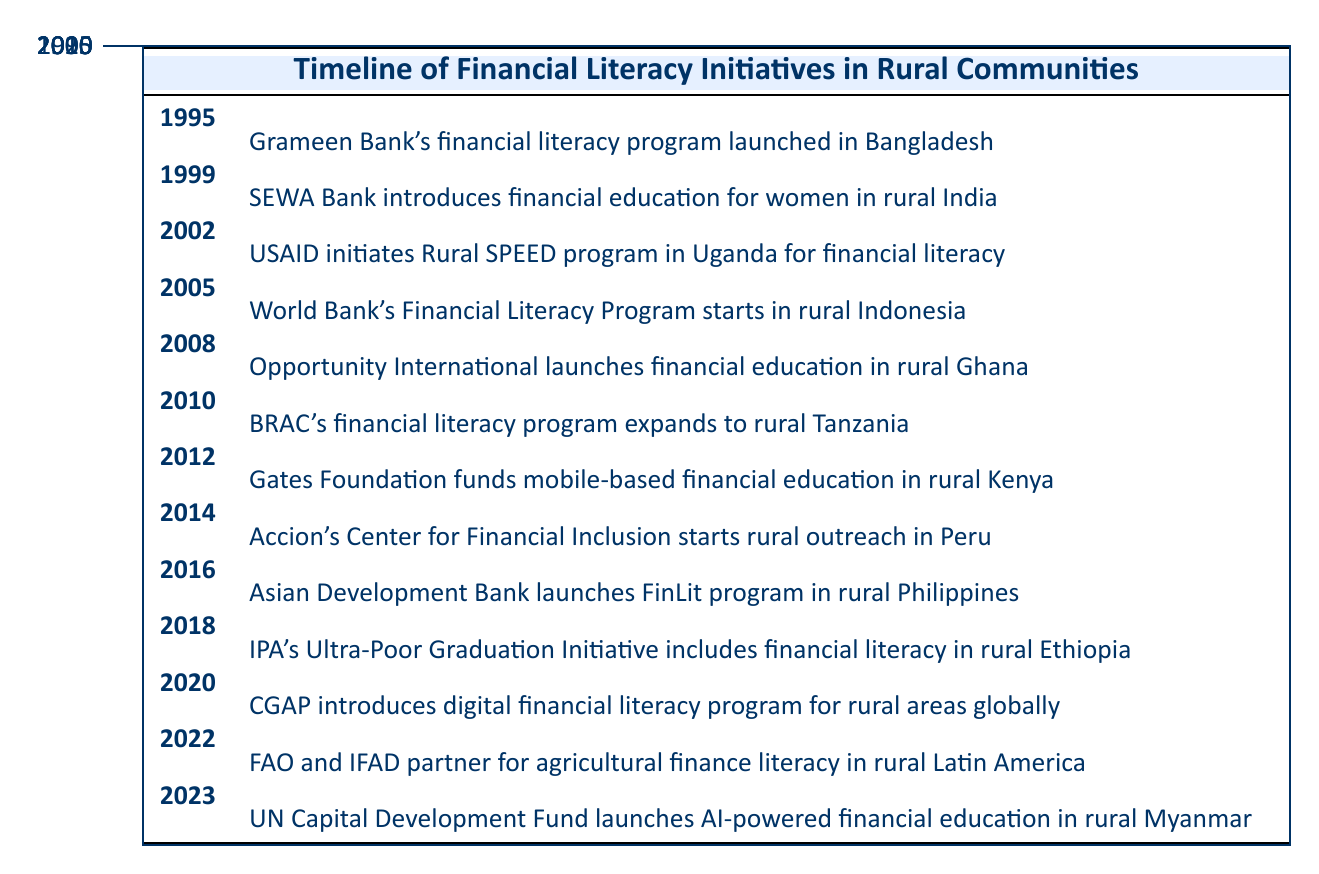What year did Grameen Bank launch its financial literacy program? From the timeline table, Grameen Bank's financial literacy program was launched in the year 1995.
Answer: 1995 How many financial literacy initiatives were launched between 2000 and 2010? The events between 2000 and 2010 are in the years 2005, 2008, and 2010. That totals to three initiatives.
Answer: 3 Did the USAID initiate a financial literacy program prior to 2002? According to the table, the USAID's Rural SPEED program was started in 2002. Thus, no financial literacy programs by USAID were initiated prior to that year.
Answer: No What was the first financial literacy program launched in Africa according to the table? In the table, the first financial literacy program mentioned in Africa is Opportunity International's financial education initiative launched in rural Ghana in 2008.
Answer: Opportunity International's financial education in rural Ghana How many years apart were the financial literacy initiatives launched in 2008 and 2010? The initiative launched in 2008 was Opportunity International's program, and the one in 2010 was BRAC's program. The difference between these years is 2010 - 2008 = 2 years.
Answer: 2 years Which initiative was funded by the Gates Foundation? The table mentions that the Gates Foundation funded mobile-based financial education in rural Kenya in 2012.
Answer: Gates Foundation's initiative in rural Kenya Identify the last financial literacy initiative listed in the table. The last entry in the timeline is from 2023, where the UN Capital Development Fund launched AI-powered financial education in rural Myanmar.
Answer: UN Capital Development Fund in rural Myanmar Was there a financial literacy initiative related to agricultural finance in Latin America? Yes, the table indicates that in 2022, FAO and IFAD partnered for agricultural finance literacy in rural Latin America.
Answer: Yes What pattern can be observed in the years when financial literacy initiatives were launched? By analyzing the timeline, there is a noticeable increase in initiatives over time, especially from 2000 onwards, suggesting a growing recognition of the need for financial literacy in rural communities.
Answer: Increasing pattern of initiatives over time 